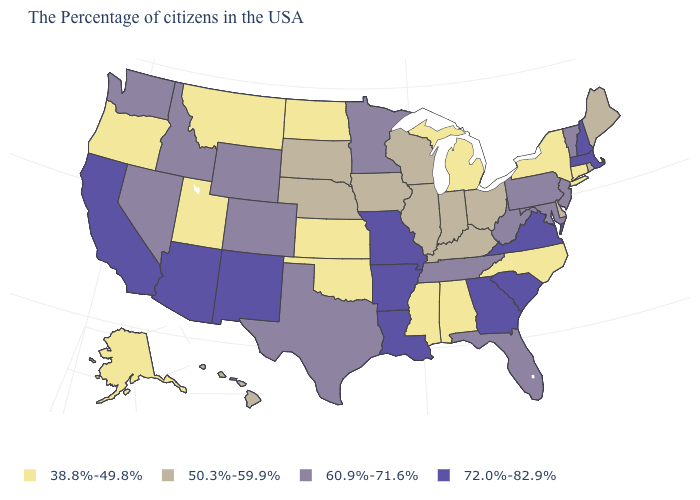Name the states that have a value in the range 72.0%-82.9%?
Write a very short answer. Massachusetts, New Hampshire, Virginia, South Carolina, Georgia, Louisiana, Missouri, Arkansas, New Mexico, Arizona, California. What is the value of California?
Short answer required. 72.0%-82.9%. What is the value of West Virginia?
Short answer required. 60.9%-71.6%. What is the value of Illinois?
Answer briefly. 50.3%-59.9%. Name the states that have a value in the range 60.9%-71.6%?
Write a very short answer. Vermont, New Jersey, Maryland, Pennsylvania, West Virginia, Florida, Tennessee, Minnesota, Texas, Wyoming, Colorado, Idaho, Nevada, Washington. Name the states that have a value in the range 50.3%-59.9%?
Be succinct. Maine, Rhode Island, Delaware, Ohio, Kentucky, Indiana, Wisconsin, Illinois, Iowa, Nebraska, South Dakota, Hawaii. Does Iowa have the highest value in the USA?
Short answer required. No. What is the value of Tennessee?
Be succinct. 60.9%-71.6%. What is the highest value in states that border Pennsylvania?
Short answer required. 60.9%-71.6%. Does New Jersey have the lowest value in the Northeast?
Be succinct. No. Which states have the lowest value in the USA?
Short answer required. Connecticut, New York, North Carolina, Michigan, Alabama, Mississippi, Kansas, Oklahoma, North Dakota, Utah, Montana, Oregon, Alaska. Which states hav the highest value in the South?
Quick response, please. Virginia, South Carolina, Georgia, Louisiana, Arkansas. Which states have the lowest value in the South?
Answer briefly. North Carolina, Alabama, Mississippi, Oklahoma. Among the states that border Louisiana , does Mississippi have the lowest value?
Keep it brief. Yes. Which states hav the highest value in the Northeast?
Concise answer only. Massachusetts, New Hampshire. 